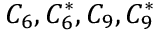Convert formula to latex. <formula><loc_0><loc_0><loc_500><loc_500>C _ { 6 } , C _ { 6 } ^ { * } , C _ { 9 } , C _ { 9 } ^ { * }</formula> 